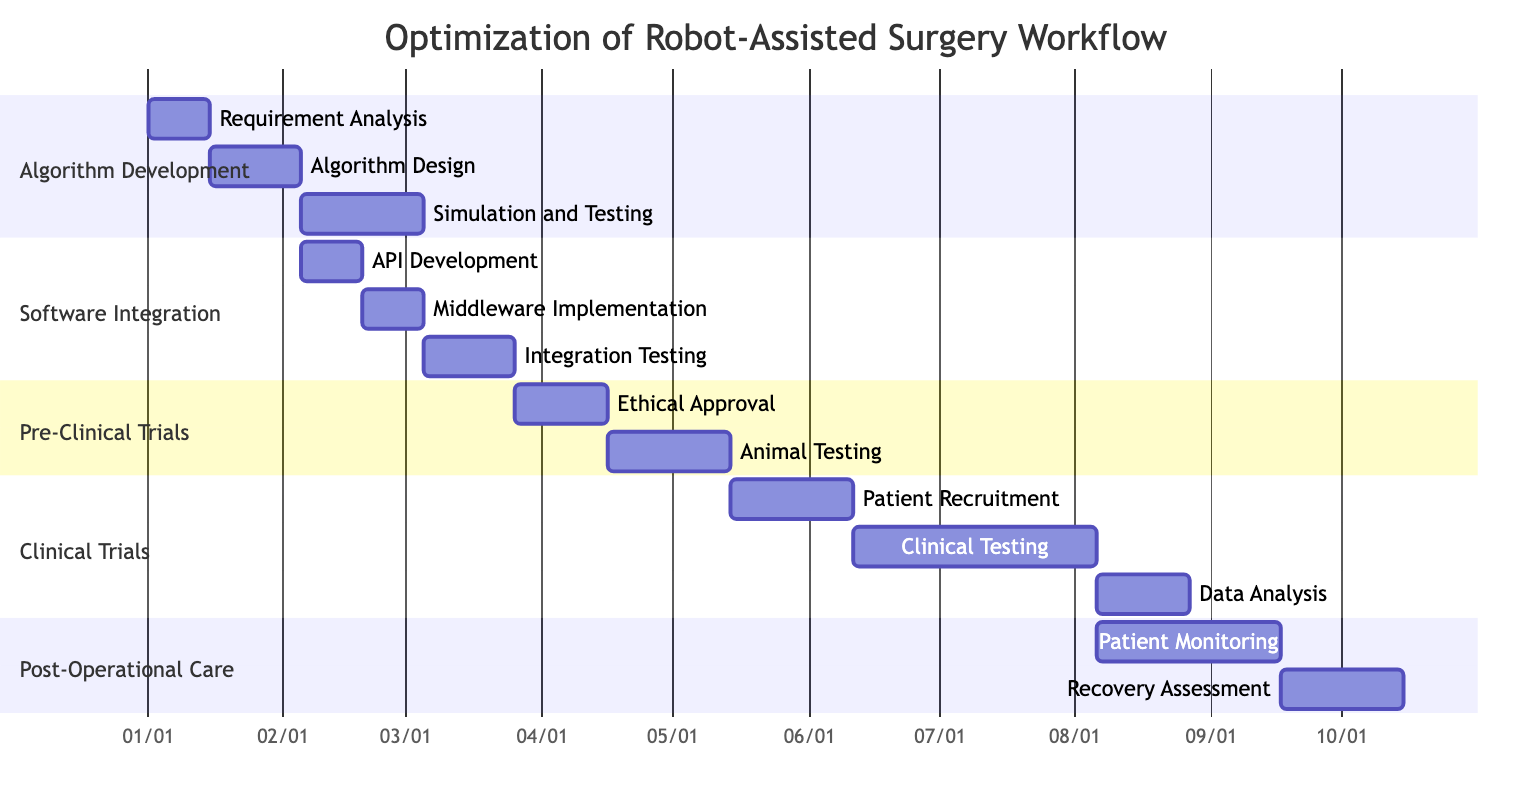What is the duration of the Algorithm Design task? The task "Algorithm Design" has a specified duration of 3 weeks in the diagram.
Answer: 3 weeks How many weeks does the Ethical Approval task take? The duration for the "Ethical Approval" task is mentioned as 3 weeks in the diagram.
Answer: 3 weeks Which task directly follows Algorithm Design? The diagram indicates that "Simulation and Testing" directly follows "Algorithm Design," as it is dependent on its completion.
Answer: Simulation and Testing After which task does Integration Testing begin? According to the diagram, "Integration Testing" begins after the "Middleware Implementation" task is completed, as it is dependent on that task.
Answer: Middleware Implementation What is the total duration for all tasks in Clinical Trials? The total duration for "Patient Recruitment" (4 weeks), "Clinical Testing" (8 weeks), and "Data Analysis" (3 weeks) adds up to 15 weeks in total.
Answer: 15 weeks How many tasks are there in the Post-Operational Care section? The Post-Operational Care section has two tasks: "Patient Monitoring" and "Recovery Assessment," making a total of two tasks in that section.
Answer: 2 tasks Which task has the longest duration overall? The "Clinical Testing" task has the longest duration of 8 weeks among all tasks shown in the diagram.
Answer: Clinical Testing What comes after Animal Testing in the workflow? The "Patient Recruitment" task follows "Animal Testing" in the workflow as indicated by the dependency relationships in the diagram.
Answer: Patient Recruitment How many weeks are allocated for patient monitoring? The duration allocated for "Patient Monitoring" is 6 weeks as depicted in the diagram.
Answer: 6 weeks 